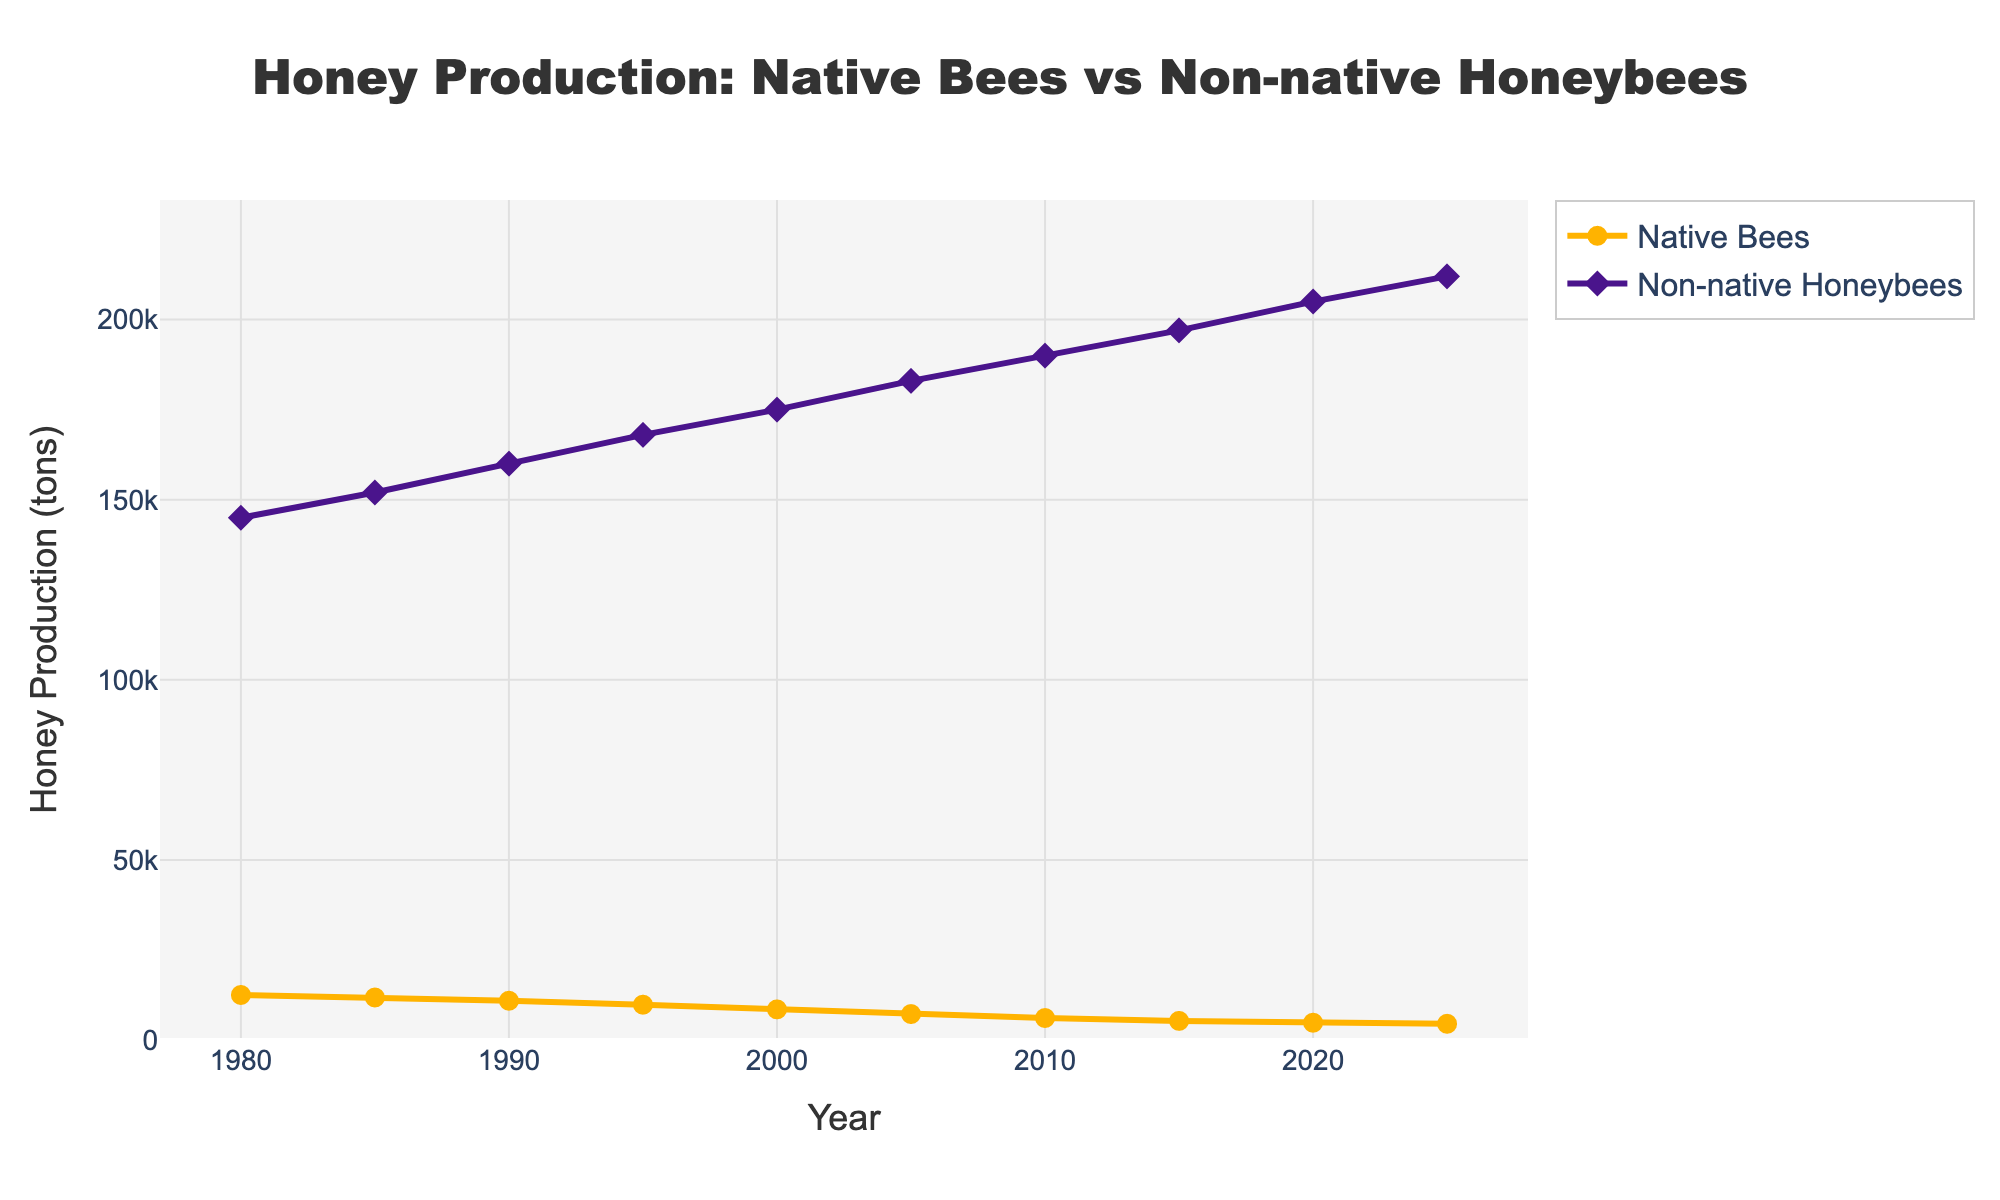What is the trend in the honey production by native bees from 1980 to 2025? Observing the line representing native bee honey production from 1980 to 2025 shows a continuous decline in honey production. The production drops from 12,500 tons in 1980 to 4,500 tons in 2025.
Answer: Continuous decline By how much did the honey production by non-native honeybees increase between 1980 and 2025? The honey production by non-native honeybees in 1980 is 145,000 tons, and it increases to 212,000 tons in 2025. The increase in production is 212,000 - 145,000 = 67,000 tons.
Answer: 67,000 tons Which year marks the largest difference in honey production between native bees and non-native honeybees? The year 2025 shows the largest difference. Native bee production is 4,500 tons, and non-native honeybee production is 212,000 tons, with the difference being 212,000 - 4,500 = 207,500 tons.
Answer: 2025 What was the average honey production by non-native honeybees from 1980 to 2025? To find the average, sum all the production values for non-native honeybees and divide by the number of years (10 data points). The sum is 145,000 + 152,000 + 160,000 + 168,000 + 175,000 + 183,000 + 190,000 + 197,000 + 205,000 + 212,000 = 1,787,000 tons. The average is 1,787,000 / 10 = 178,700 tons.
Answer: 178,700 tons By what percentage did the honey production by native bees decrease from 1980 to 2025? Initial production in 1980 is 12,500 tons, and in 2025 it is 4,500 tons. The decrease in production is 12,500 - 4,500 = 8,000 tons. To find the percentage decrease: (8,000 / 12,500) * 100% = 64%.
Answer: 64% What color represents the line for non-native honeybee honey production? The line for non-native honeybee honey production on the chart is represented by a purple color.
Answer: Purple In which year did native bee honey production fall below 6,000 tons? By reviewing the chart, we see that in 2010, native bee honey production falls to 6,100 tons and declines further in 2015 to 5,300 tons. So, it happens between 2010 and 2015, specifically in 2015.
Answer: 2015 